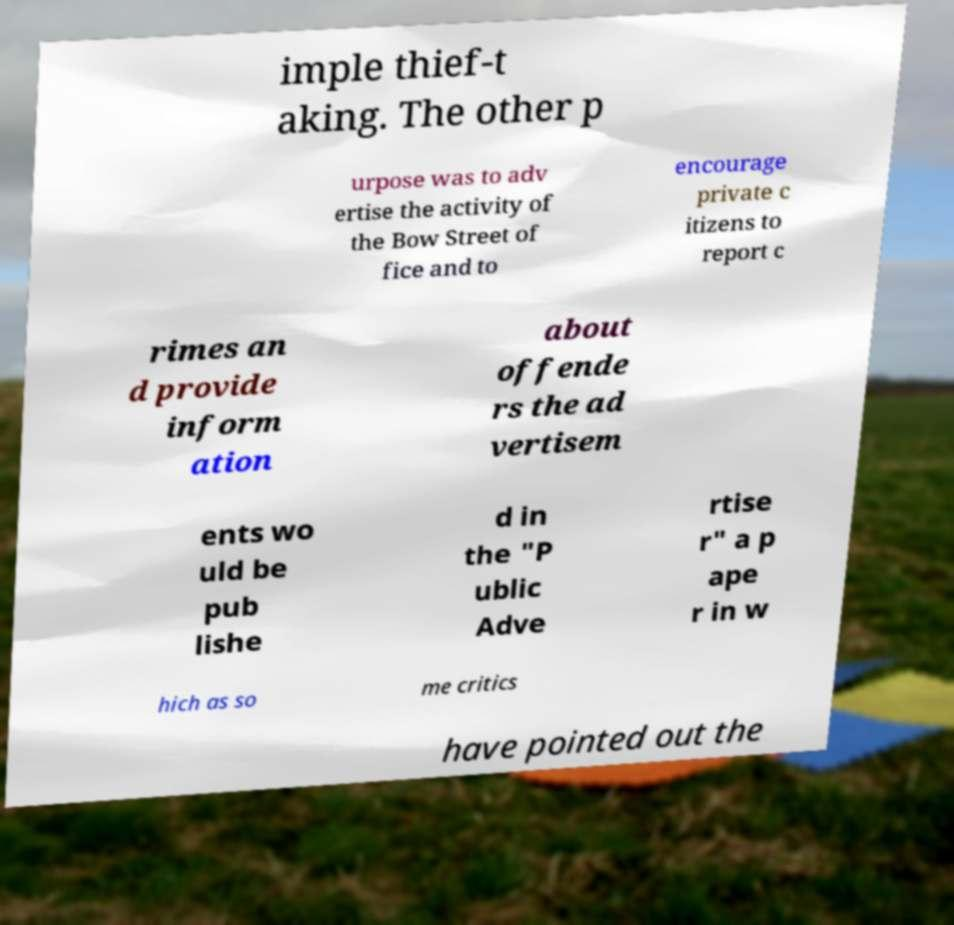Please read and relay the text visible in this image. What does it say? imple thief-t aking. The other p urpose was to adv ertise the activity of the Bow Street of fice and to encourage private c itizens to report c rimes an d provide inform ation about offende rs the ad vertisem ents wo uld be pub lishe d in the "P ublic Adve rtise r" a p ape r in w hich as so me critics have pointed out the 